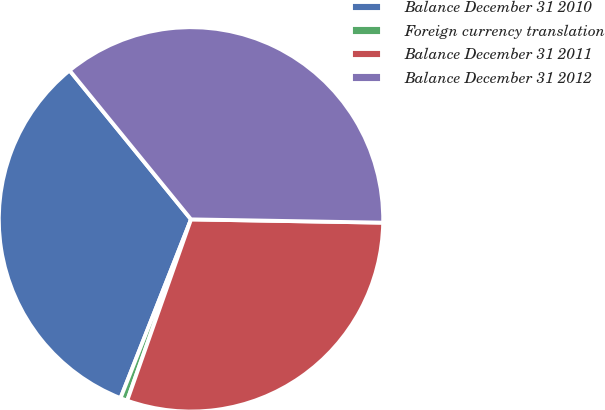Convert chart to OTSL. <chart><loc_0><loc_0><loc_500><loc_500><pie_chart><fcel>Balance December 31 2010<fcel>Foreign currency translation<fcel>Balance December 31 2011<fcel>Balance December 31 2012<nl><fcel>33.14%<fcel>0.59%<fcel>30.12%<fcel>36.16%<nl></chart> 